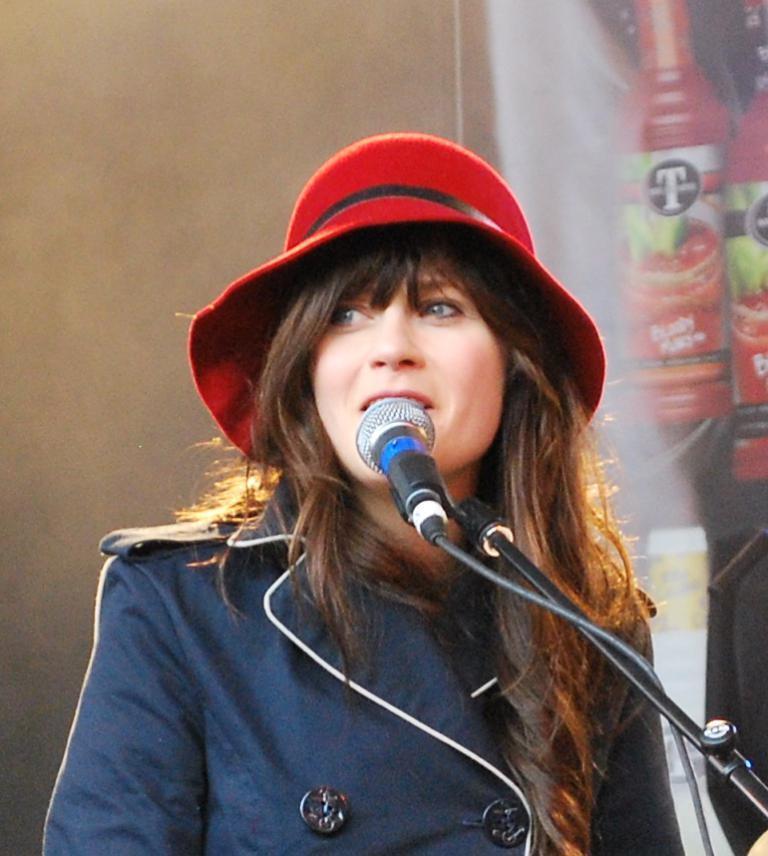Could you give a brief overview of what you see in this image? In this image there is a girl in the middle. In front of her there is a mic. In the background there is a banner. The girl is wearing the red colour hat. 